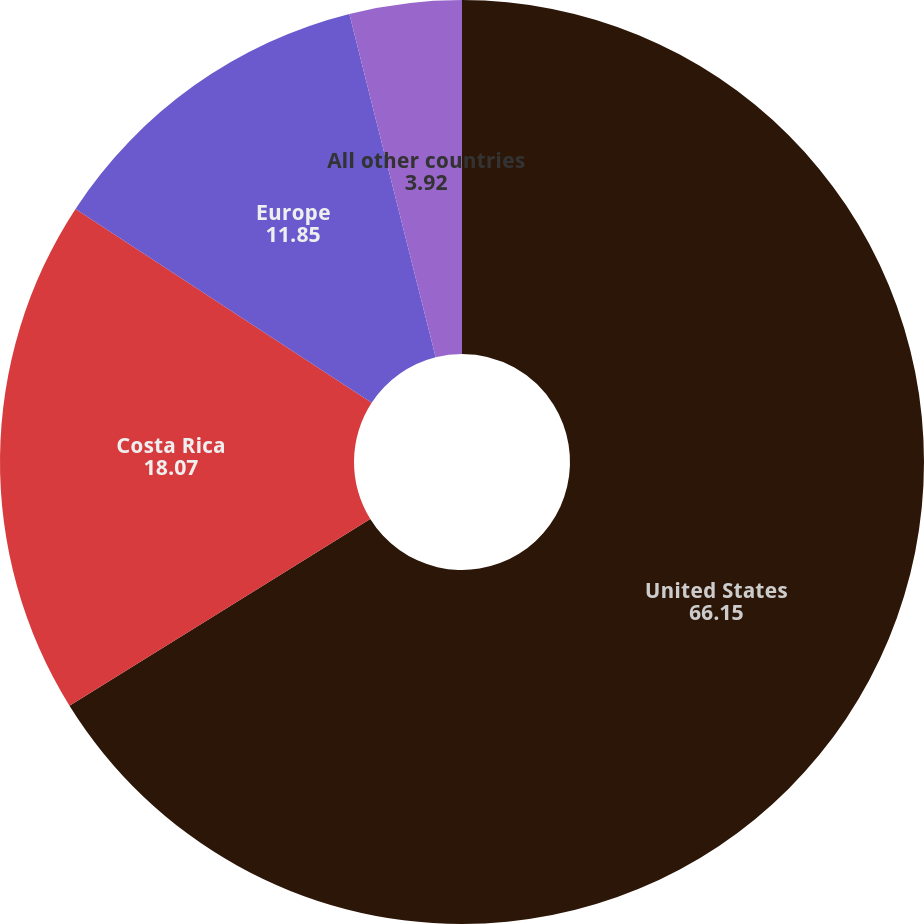Convert chart to OTSL. <chart><loc_0><loc_0><loc_500><loc_500><pie_chart><fcel>United States<fcel>Costa Rica<fcel>Europe<fcel>All other countries<nl><fcel>66.15%<fcel>18.07%<fcel>11.85%<fcel>3.92%<nl></chart> 